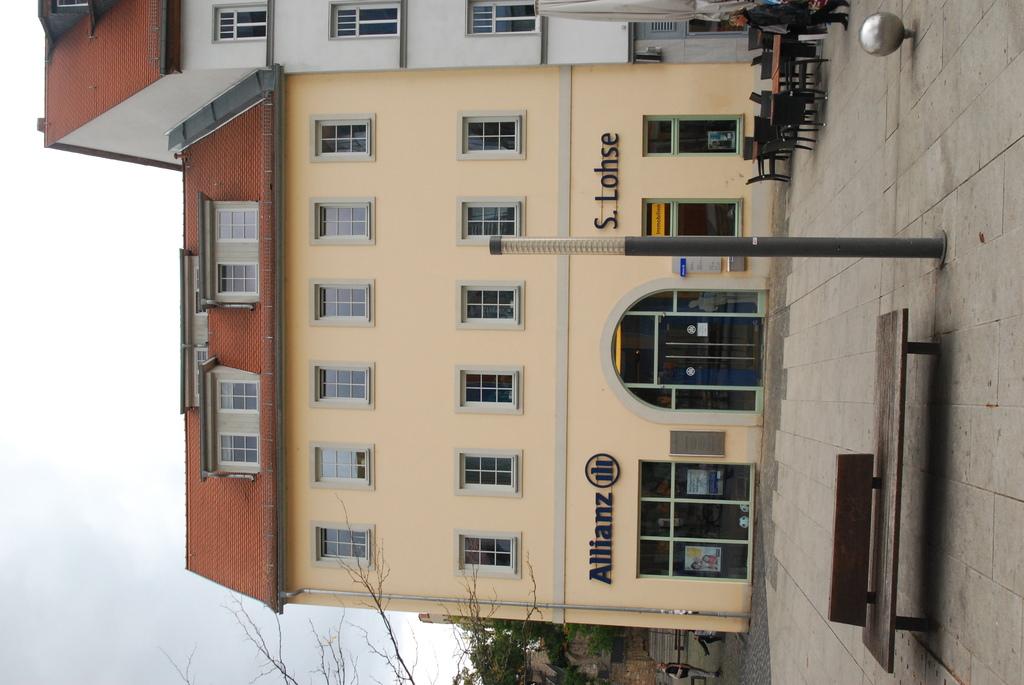What company runs out of this building?
Ensure brevity in your answer.  Allianz. What is the store on the far right?
Your response must be concise. S. lohse. 